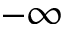<formula> <loc_0><loc_0><loc_500><loc_500>- \infty</formula> 